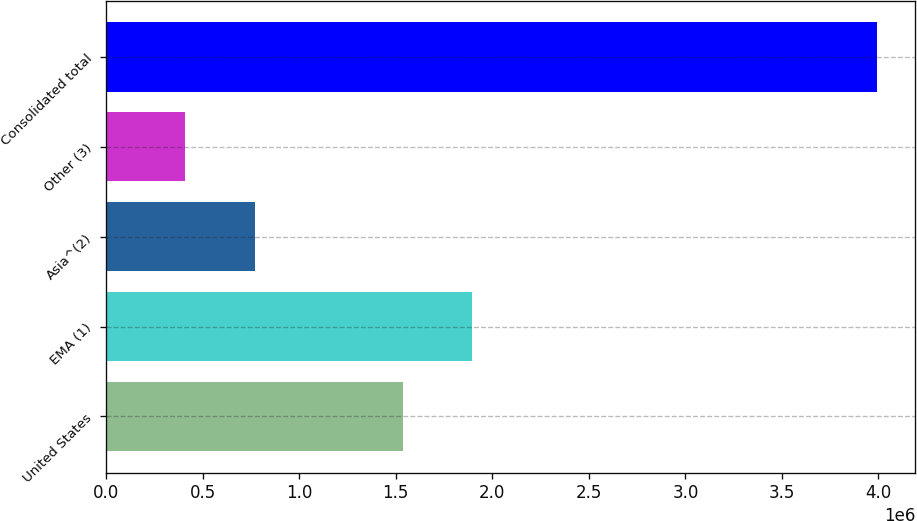<chart> <loc_0><loc_0><loc_500><loc_500><bar_chart><fcel>United States<fcel>EMA (1)<fcel>Asia^(2)<fcel>Other (3)<fcel>Consolidated total<nl><fcel>1.53778e+06<fcel>1.8958e+06<fcel>768319<fcel>410300<fcel>3.99049e+06<nl></chart> 